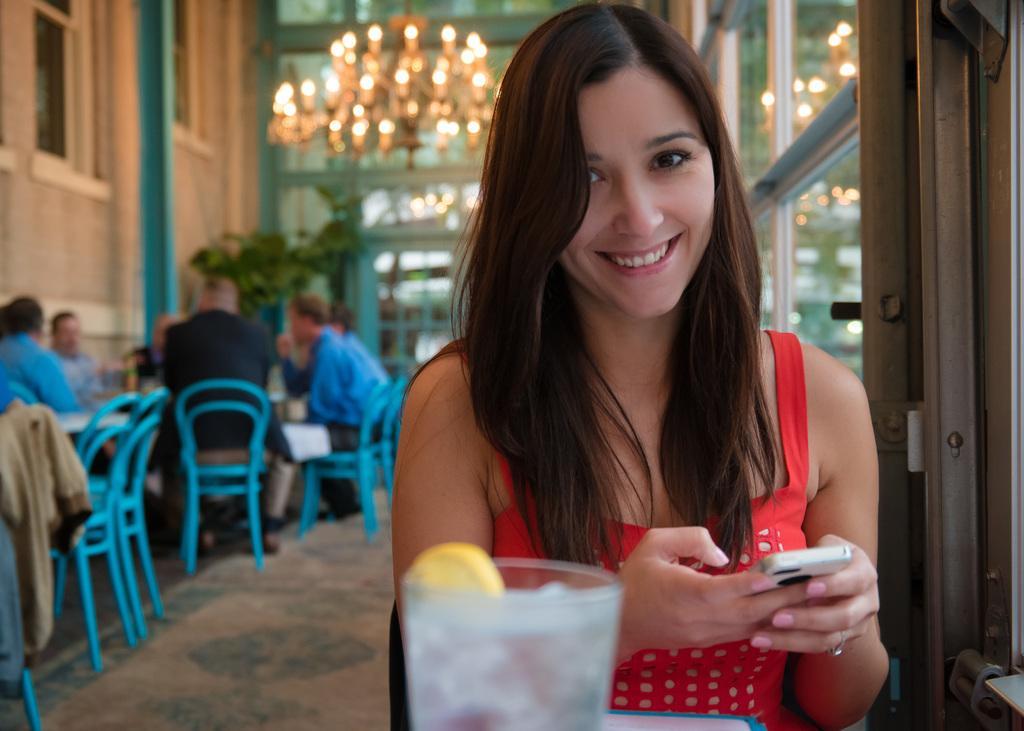How would you summarize this image in a sentence or two? In the picture I can see a woman sitting on a chair and she is on the right side. She is wearing a red color top and holding a mobile phone. There is a pretty smile on her face. I can see the glass at the bottom of the picture. I can see a few persons sitting on the chairs on the left side. I can see the glass windows on the top left side and the right side of the picture. 